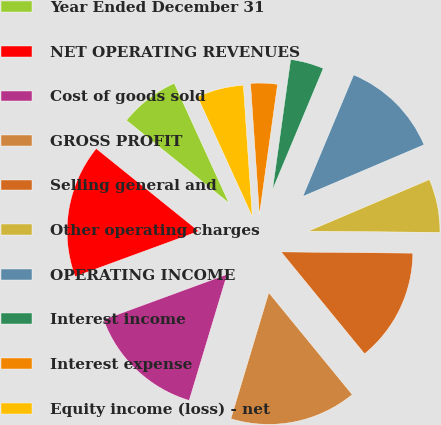Convert chart. <chart><loc_0><loc_0><loc_500><loc_500><pie_chart><fcel>Year Ended December 31<fcel>NET OPERATING REVENUES<fcel>Cost of goods sold<fcel>GROSS PROFIT<fcel>Selling general and<fcel>Other operating charges<fcel>OPERATING INCOME<fcel>Interest income<fcel>Interest expense<fcel>Equity income (loss) - net<nl><fcel>7.38%<fcel>16.39%<fcel>14.75%<fcel>15.57%<fcel>13.93%<fcel>6.56%<fcel>12.29%<fcel>4.1%<fcel>3.28%<fcel>5.74%<nl></chart> 